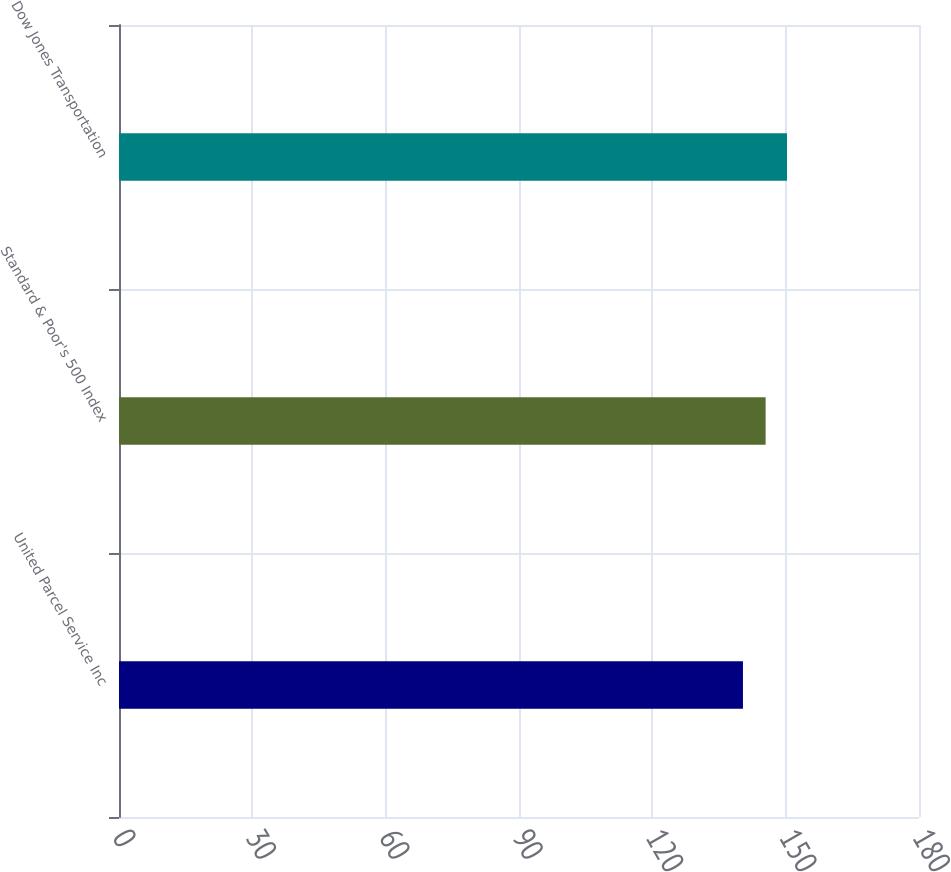<chart> <loc_0><loc_0><loc_500><loc_500><bar_chart><fcel>United Parcel Service Inc<fcel>Standard & Poor's 500 Index<fcel>Dow Jones Transportation<nl><fcel>140.39<fcel>145.49<fcel>150.3<nl></chart> 